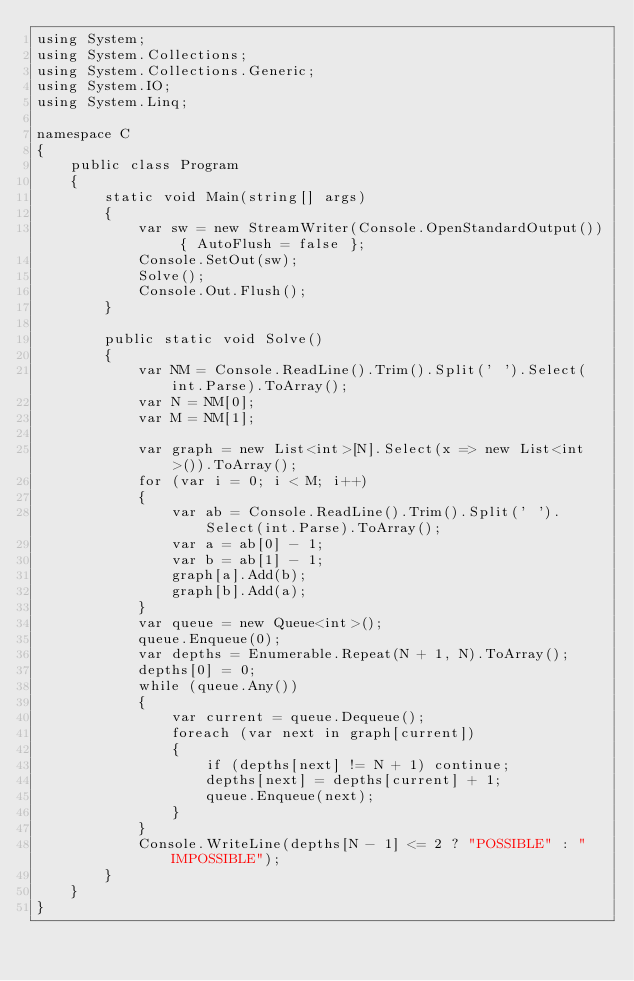Convert code to text. <code><loc_0><loc_0><loc_500><loc_500><_C#_>using System;
using System.Collections;
using System.Collections.Generic;
using System.IO;
using System.Linq;

namespace C
{
    public class Program
    {
        static void Main(string[] args)
        {
            var sw = new StreamWriter(Console.OpenStandardOutput()) { AutoFlush = false };
            Console.SetOut(sw);
            Solve();
            Console.Out.Flush();
        }

        public static void Solve()
        {
            var NM = Console.ReadLine().Trim().Split(' ').Select(int.Parse).ToArray();
            var N = NM[0];
            var M = NM[1];

            var graph = new List<int>[N].Select(x => new List<int>()).ToArray();
            for (var i = 0; i < M; i++)
            {
                var ab = Console.ReadLine().Trim().Split(' ').Select(int.Parse).ToArray();
                var a = ab[0] - 1;
                var b = ab[1] - 1;
                graph[a].Add(b);
                graph[b].Add(a);
            }
            var queue = new Queue<int>();
            queue.Enqueue(0);
            var depths = Enumerable.Repeat(N + 1, N).ToArray();
            depths[0] = 0;
            while (queue.Any())
            {
                var current = queue.Dequeue();
                foreach (var next in graph[current])
                {
                    if (depths[next] != N + 1) continue;
                    depths[next] = depths[current] + 1;
                    queue.Enqueue(next);
                }
            }
            Console.WriteLine(depths[N - 1] <= 2 ? "POSSIBLE" : "IMPOSSIBLE");
        }
    }
}
</code> 